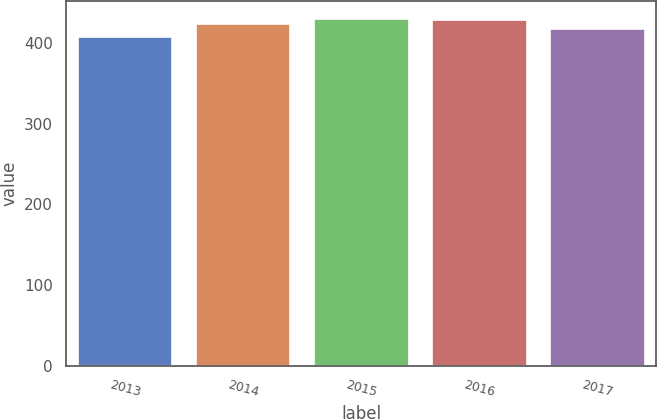<chart> <loc_0><loc_0><loc_500><loc_500><bar_chart><fcel>2013<fcel>2014<fcel>2015<fcel>2016<fcel>2017<nl><fcel>407<fcel>424<fcel>430.2<fcel>428<fcel>417<nl></chart> 